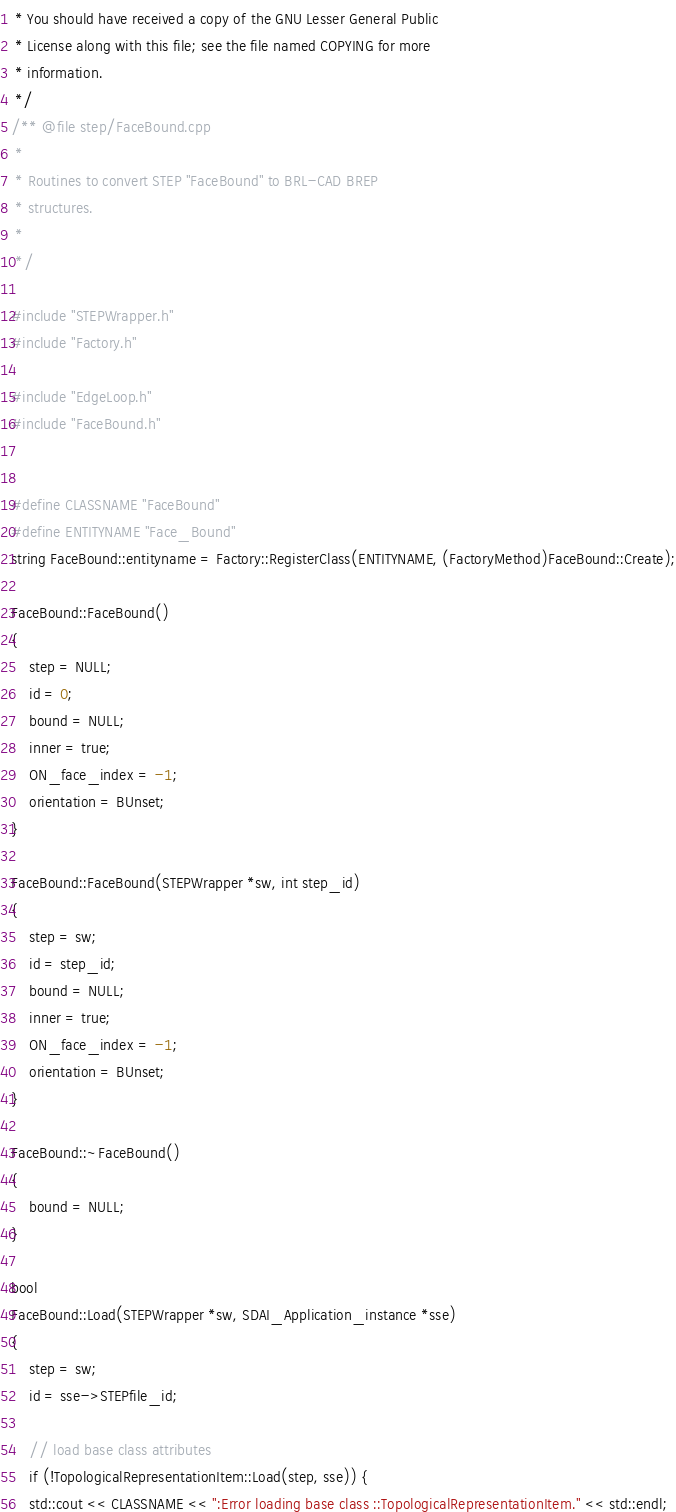<code> <loc_0><loc_0><loc_500><loc_500><_C++_> * You should have received a copy of the GNU Lesser General Public
 * License along with this file; see the file named COPYING for more
 * information.
 */
/** @file step/FaceBound.cpp
 *
 * Routines to convert STEP "FaceBound" to BRL-CAD BREP
 * structures.
 *
 */

#include "STEPWrapper.h"
#include "Factory.h"

#include "EdgeLoop.h"
#include "FaceBound.h"


#define CLASSNAME "FaceBound"
#define ENTITYNAME "Face_Bound"
string FaceBound::entityname = Factory::RegisterClass(ENTITYNAME, (FactoryMethod)FaceBound::Create);

FaceBound::FaceBound()
{
    step = NULL;
    id = 0;
    bound = NULL;
    inner = true;
    ON_face_index = -1;
    orientation = BUnset;
}

FaceBound::FaceBound(STEPWrapper *sw, int step_id)
{
    step = sw;
    id = step_id;
    bound = NULL;
    inner = true;
    ON_face_index = -1;
    orientation = BUnset;
}

FaceBound::~FaceBound()
{
    bound = NULL;
}

bool
FaceBound::Load(STEPWrapper *sw, SDAI_Application_instance *sse)
{
    step = sw;
    id = sse->STEPfile_id;

    // load base class attributes
    if (!TopologicalRepresentationItem::Load(step, sse)) {
	std::cout << CLASSNAME << ":Error loading base class ::TopologicalRepresentationItem." << std::endl;</code> 